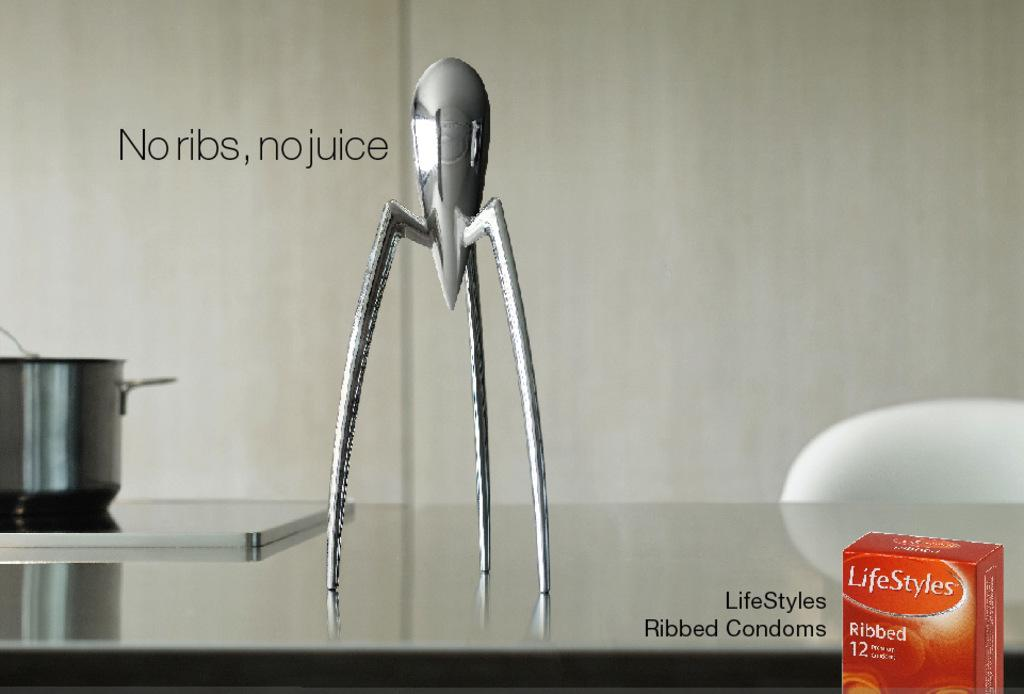<image>
Provide a brief description of the given image. An add for LifeStyles ribbed condoms shows a chrome tripod on a table. 